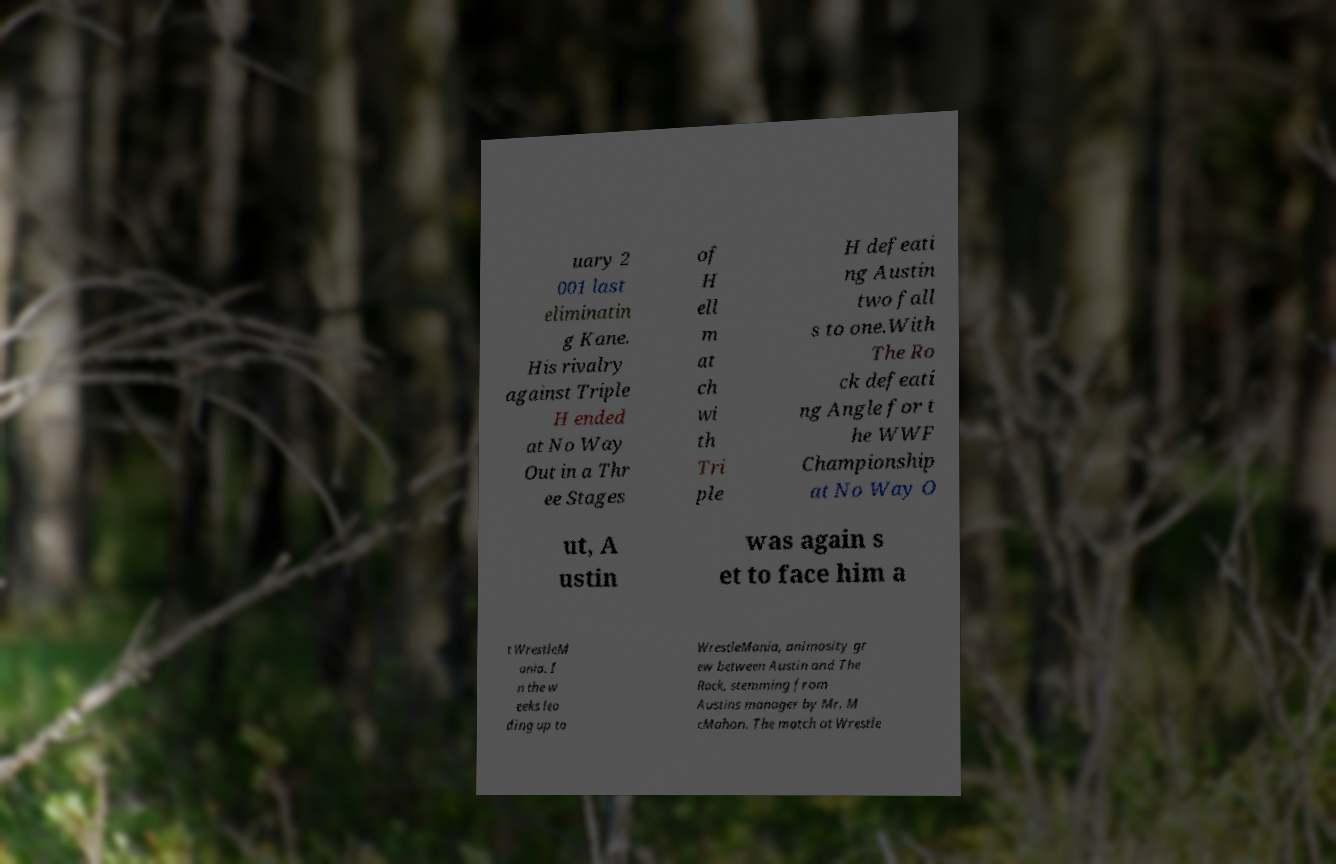Could you assist in decoding the text presented in this image and type it out clearly? uary 2 001 last eliminatin g Kane. His rivalry against Triple H ended at No Way Out in a Thr ee Stages of H ell m at ch wi th Tri ple H defeati ng Austin two fall s to one.With The Ro ck defeati ng Angle for t he WWF Championship at No Way O ut, A ustin was again s et to face him a t WrestleM ania. I n the w eeks lea ding up to WrestleMania, animosity gr ew between Austin and The Rock, stemming from Austins manager by Mr. M cMahon. The match at Wrestle 